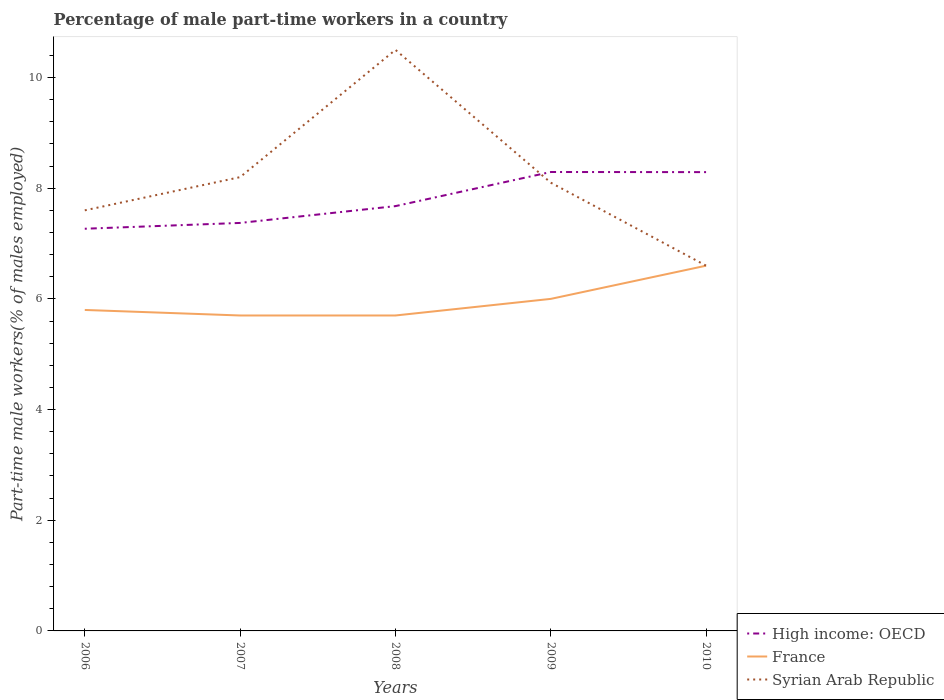Does the line corresponding to High income: OECD intersect with the line corresponding to Syrian Arab Republic?
Keep it short and to the point. Yes. Across all years, what is the maximum percentage of male part-time workers in Syrian Arab Republic?
Your answer should be compact. 6.6. In which year was the percentage of male part-time workers in High income: OECD maximum?
Ensure brevity in your answer.  2006. What is the total percentage of male part-time workers in High income: OECD in the graph?
Offer a very short reply. -0.41. What is the difference between the highest and the second highest percentage of male part-time workers in Syrian Arab Republic?
Make the answer very short. 3.9. Is the percentage of male part-time workers in Syrian Arab Republic strictly greater than the percentage of male part-time workers in France over the years?
Your answer should be very brief. No. What is the difference between two consecutive major ticks on the Y-axis?
Offer a terse response. 2. Are the values on the major ticks of Y-axis written in scientific E-notation?
Provide a succinct answer. No. Does the graph contain any zero values?
Make the answer very short. No. Does the graph contain grids?
Offer a very short reply. No. How are the legend labels stacked?
Ensure brevity in your answer.  Vertical. What is the title of the graph?
Provide a succinct answer. Percentage of male part-time workers in a country. Does "Small states" appear as one of the legend labels in the graph?
Provide a succinct answer. No. What is the label or title of the Y-axis?
Your answer should be compact. Part-time male workers(% of males employed). What is the Part-time male workers(% of males employed) in High income: OECD in 2006?
Make the answer very short. 7.27. What is the Part-time male workers(% of males employed) of France in 2006?
Offer a very short reply. 5.8. What is the Part-time male workers(% of males employed) in Syrian Arab Republic in 2006?
Offer a terse response. 7.6. What is the Part-time male workers(% of males employed) in High income: OECD in 2007?
Provide a short and direct response. 7.37. What is the Part-time male workers(% of males employed) of France in 2007?
Give a very brief answer. 5.7. What is the Part-time male workers(% of males employed) in Syrian Arab Republic in 2007?
Ensure brevity in your answer.  8.2. What is the Part-time male workers(% of males employed) in High income: OECD in 2008?
Provide a succinct answer. 7.68. What is the Part-time male workers(% of males employed) of France in 2008?
Give a very brief answer. 5.7. What is the Part-time male workers(% of males employed) in Syrian Arab Republic in 2008?
Offer a terse response. 10.5. What is the Part-time male workers(% of males employed) of High income: OECD in 2009?
Provide a short and direct response. 8.29. What is the Part-time male workers(% of males employed) in Syrian Arab Republic in 2009?
Make the answer very short. 8.1. What is the Part-time male workers(% of males employed) in High income: OECD in 2010?
Ensure brevity in your answer.  8.29. What is the Part-time male workers(% of males employed) in France in 2010?
Your answer should be compact. 6.6. What is the Part-time male workers(% of males employed) of Syrian Arab Republic in 2010?
Offer a very short reply. 6.6. Across all years, what is the maximum Part-time male workers(% of males employed) in High income: OECD?
Provide a short and direct response. 8.29. Across all years, what is the maximum Part-time male workers(% of males employed) in France?
Offer a very short reply. 6.6. Across all years, what is the maximum Part-time male workers(% of males employed) of Syrian Arab Republic?
Your answer should be compact. 10.5. Across all years, what is the minimum Part-time male workers(% of males employed) in High income: OECD?
Your answer should be compact. 7.27. Across all years, what is the minimum Part-time male workers(% of males employed) in France?
Offer a terse response. 5.7. Across all years, what is the minimum Part-time male workers(% of males employed) in Syrian Arab Republic?
Make the answer very short. 6.6. What is the total Part-time male workers(% of males employed) of High income: OECD in the graph?
Make the answer very short. 38.9. What is the total Part-time male workers(% of males employed) of France in the graph?
Your answer should be very brief. 29.8. What is the difference between the Part-time male workers(% of males employed) in High income: OECD in 2006 and that in 2007?
Provide a succinct answer. -0.1. What is the difference between the Part-time male workers(% of males employed) in High income: OECD in 2006 and that in 2008?
Keep it short and to the point. -0.41. What is the difference between the Part-time male workers(% of males employed) of High income: OECD in 2006 and that in 2009?
Keep it short and to the point. -1.03. What is the difference between the Part-time male workers(% of males employed) of France in 2006 and that in 2009?
Offer a terse response. -0.2. What is the difference between the Part-time male workers(% of males employed) of Syrian Arab Republic in 2006 and that in 2009?
Give a very brief answer. -0.5. What is the difference between the Part-time male workers(% of males employed) in High income: OECD in 2006 and that in 2010?
Your answer should be very brief. -1.02. What is the difference between the Part-time male workers(% of males employed) of High income: OECD in 2007 and that in 2008?
Provide a short and direct response. -0.3. What is the difference between the Part-time male workers(% of males employed) in Syrian Arab Republic in 2007 and that in 2008?
Ensure brevity in your answer.  -2.3. What is the difference between the Part-time male workers(% of males employed) in High income: OECD in 2007 and that in 2009?
Your response must be concise. -0.92. What is the difference between the Part-time male workers(% of males employed) in Syrian Arab Republic in 2007 and that in 2009?
Ensure brevity in your answer.  0.1. What is the difference between the Part-time male workers(% of males employed) of High income: OECD in 2007 and that in 2010?
Provide a short and direct response. -0.92. What is the difference between the Part-time male workers(% of males employed) of France in 2007 and that in 2010?
Offer a terse response. -0.9. What is the difference between the Part-time male workers(% of males employed) in Syrian Arab Republic in 2007 and that in 2010?
Provide a succinct answer. 1.6. What is the difference between the Part-time male workers(% of males employed) in High income: OECD in 2008 and that in 2009?
Offer a very short reply. -0.62. What is the difference between the Part-time male workers(% of males employed) in France in 2008 and that in 2009?
Keep it short and to the point. -0.3. What is the difference between the Part-time male workers(% of males employed) in Syrian Arab Republic in 2008 and that in 2009?
Your answer should be compact. 2.4. What is the difference between the Part-time male workers(% of males employed) of High income: OECD in 2008 and that in 2010?
Your response must be concise. -0.61. What is the difference between the Part-time male workers(% of males employed) in Syrian Arab Republic in 2008 and that in 2010?
Keep it short and to the point. 3.9. What is the difference between the Part-time male workers(% of males employed) of High income: OECD in 2009 and that in 2010?
Provide a short and direct response. 0. What is the difference between the Part-time male workers(% of males employed) of France in 2009 and that in 2010?
Your response must be concise. -0.6. What is the difference between the Part-time male workers(% of males employed) of High income: OECD in 2006 and the Part-time male workers(% of males employed) of France in 2007?
Offer a terse response. 1.57. What is the difference between the Part-time male workers(% of males employed) in High income: OECD in 2006 and the Part-time male workers(% of males employed) in Syrian Arab Republic in 2007?
Ensure brevity in your answer.  -0.93. What is the difference between the Part-time male workers(% of males employed) in High income: OECD in 2006 and the Part-time male workers(% of males employed) in France in 2008?
Your answer should be very brief. 1.57. What is the difference between the Part-time male workers(% of males employed) in High income: OECD in 2006 and the Part-time male workers(% of males employed) in Syrian Arab Republic in 2008?
Offer a very short reply. -3.23. What is the difference between the Part-time male workers(% of males employed) in High income: OECD in 2006 and the Part-time male workers(% of males employed) in France in 2009?
Your response must be concise. 1.27. What is the difference between the Part-time male workers(% of males employed) of High income: OECD in 2006 and the Part-time male workers(% of males employed) of Syrian Arab Republic in 2009?
Your answer should be very brief. -0.83. What is the difference between the Part-time male workers(% of males employed) in France in 2006 and the Part-time male workers(% of males employed) in Syrian Arab Republic in 2009?
Offer a very short reply. -2.3. What is the difference between the Part-time male workers(% of males employed) in High income: OECD in 2006 and the Part-time male workers(% of males employed) in France in 2010?
Offer a very short reply. 0.67. What is the difference between the Part-time male workers(% of males employed) of High income: OECD in 2006 and the Part-time male workers(% of males employed) of Syrian Arab Republic in 2010?
Give a very brief answer. 0.67. What is the difference between the Part-time male workers(% of males employed) in High income: OECD in 2007 and the Part-time male workers(% of males employed) in France in 2008?
Keep it short and to the point. 1.67. What is the difference between the Part-time male workers(% of males employed) in High income: OECD in 2007 and the Part-time male workers(% of males employed) in Syrian Arab Republic in 2008?
Offer a very short reply. -3.13. What is the difference between the Part-time male workers(% of males employed) of France in 2007 and the Part-time male workers(% of males employed) of Syrian Arab Republic in 2008?
Provide a succinct answer. -4.8. What is the difference between the Part-time male workers(% of males employed) of High income: OECD in 2007 and the Part-time male workers(% of males employed) of France in 2009?
Ensure brevity in your answer.  1.37. What is the difference between the Part-time male workers(% of males employed) in High income: OECD in 2007 and the Part-time male workers(% of males employed) in Syrian Arab Republic in 2009?
Offer a terse response. -0.73. What is the difference between the Part-time male workers(% of males employed) of France in 2007 and the Part-time male workers(% of males employed) of Syrian Arab Republic in 2009?
Your response must be concise. -2.4. What is the difference between the Part-time male workers(% of males employed) of High income: OECD in 2007 and the Part-time male workers(% of males employed) of France in 2010?
Ensure brevity in your answer.  0.77. What is the difference between the Part-time male workers(% of males employed) in High income: OECD in 2007 and the Part-time male workers(% of males employed) in Syrian Arab Republic in 2010?
Keep it short and to the point. 0.77. What is the difference between the Part-time male workers(% of males employed) of High income: OECD in 2008 and the Part-time male workers(% of males employed) of France in 2009?
Your answer should be compact. 1.68. What is the difference between the Part-time male workers(% of males employed) in High income: OECD in 2008 and the Part-time male workers(% of males employed) in Syrian Arab Republic in 2009?
Your response must be concise. -0.42. What is the difference between the Part-time male workers(% of males employed) of High income: OECD in 2008 and the Part-time male workers(% of males employed) of France in 2010?
Make the answer very short. 1.08. What is the difference between the Part-time male workers(% of males employed) of High income: OECD in 2008 and the Part-time male workers(% of males employed) of Syrian Arab Republic in 2010?
Your response must be concise. 1.08. What is the difference between the Part-time male workers(% of males employed) in France in 2008 and the Part-time male workers(% of males employed) in Syrian Arab Republic in 2010?
Your answer should be compact. -0.9. What is the difference between the Part-time male workers(% of males employed) of High income: OECD in 2009 and the Part-time male workers(% of males employed) of France in 2010?
Your answer should be compact. 1.69. What is the difference between the Part-time male workers(% of males employed) of High income: OECD in 2009 and the Part-time male workers(% of males employed) of Syrian Arab Republic in 2010?
Keep it short and to the point. 1.69. What is the difference between the Part-time male workers(% of males employed) in France in 2009 and the Part-time male workers(% of males employed) in Syrian Arab Republic in 2010?
Offer a very short reply. -0.6. What is the average Part-time male workers(% of males employed) in High income: OECD per year?
Ensure brevity in your answer.  7.78. What is the average Part-time male workers(% of males employed) in France per year?
Make the answer very short. 5.96. What is the average Part-time male workers(% of males employed) in Syrian Arab Republic per year?
Keep it short and to the point. 8.2. In the year 2006, what is the difference between the Part-time male workers(% of males employed) of High income: OECD and Part-time male workers(% of males employed) of France?
Keep it short and to the point. 1.47. In the year 2006, what is the difference between the Part-time male workers(% of males employed) of High income: OECD and Part-time male workers(% of males employed) of Syrian Arab Republic?
Ensure brevity in your answer.  -0.33. In the year 2007, what is the difference between the Part-time male workers(% of males employed) in High income: OECD and Part-time male workers(% of males employed) in France?
Provide a succinct answer. 1.67. In the year 2007, what is the difference between the Part-time male workers(% of males employed) of High income: OECD and Part-time male workers(% of males employed) of Syrian Arab Republic?
Your response must be concise. -0.83. In the year 2008, what is the difference between the Part-time male workers(% of males employed) of High income: OECD and Part-time male workers(% of males employed) of France?
Provide a short and direct response. 1.98. In the year 2008, what is the difference between the Part-time male workers(% of males employed) in High income: OECD and Part-time male workers(% of males employed) in Syrian Arab Republic?
Make the answer very short. -2.82. In the year 2009, what is the difference between the Part-time male workers(% of males employed) of High income: OECD and Part-time male workers(% of males employed) of France?
Your response must be concise. 2.29. In the year 2009, what is the difference between the Part-time male workers(% of males employed) in High income: OECD and Part-time male workers(% of males employed) in Syrian Arab Republic?
Give a very brief answer. 0.19. In the year 2010, what is the difference between the Part-time male workers(% of males employed) of High income: OECD and Part-time male workers(% of males employed) of France?
Your answer should be very brief. 1.69. In the year 2010, what is the difference between the Part-time male workers(% of males employed) of High income: OECD and Part-time male workers(% of males employed) of Syrian Arab Republic?
Ensure brevity in your answer.  1.69. What is the ratio of the Part-time male workers(% of males employed) in High income: OECD in 2006 to that in 2007?
Provide a succinct answer. 0.99. What is the ratio of the Part-time male workers(% of males employed) in France in 2006 to that in 2007?
Offer a terse response. 1.02. What is the ratio of the Part-time male workers(% of males employed) of Syrian Arab Republic in 2006 to that in 2007?
Make the answer very short. 0.93. What is the ratio of the Part-time male workers(% of males employed) in High income: OECD in 2006 to that in 2008?
Your answer should be very brief. 0.95. What is the ratio of the Part-time male workers(% of males employed) of France in 2006 to that in 2008?
Offer a terse response. 1.02. What is the ratio of the Part-time male workers(% of males employed) in Syrian Arab Republic in 2006 to that in 2008?
Make the answer very short. 0.72. What is the ratio of the Part-time male workers(% of males employed) of High income: OECD in 2006 to that in 2009?
Offer a terse response. 0.88. What is the ratio of the Part-time male workers(% of males employed) in France in 2006 to that in 2009?
Your response must be concise. 0.97. What is the ratio of the Part-time male workers(% of males employed) in Syrian Arab Republic in 2006 to that in 2009?
Your answer should be very brief. 0.94. What is the ratio of the Part-time male workers(% of males employed) of High income: OECD in 2006 to that in 2010?
Ensure brevity in your answer.  0.88. What is the ratio of the Part-time male workers(% of males employed) of France in 2006 to that in 2010?
Your answer should be compact. 0.88. What is the ratio of the Part-time male workers(% of males employed) of Syrian Arab Republic in 2006 to that in 2010?
Make the answer very short. 1.15. What is the ratio of the Part-time male workers(% of males employed) of High income: OECD in 2007 to that in 2008?
Offer a terse response. 0.96. What is the ratio of the Part-time male workers(% of males employed) in France in 2007 to that in 2008?
Keep it short and to the point. 1. What is the ratio of the Part-time male workers(% of males employed) of Syrian Arab Republic in 2007 to that in 2008?
Your response must be concise. 0.78. What is the ratio of the Part-time male workers(% of males employed) of High income: OECD in 2007 to that in 2009?
Ensure brevity in your answer.  0.89. What is the ratio of the Part-time male workers(% of males employed) of Syrian Arab Republic in 2007 to that in 2009?
Keep it short and to the point. 1.01. What is the ratio of the Part-time male workers(% of males employed) of High income: OECD in 2007 to that in 2010?
Your response must be concise. 0.89. What is the ratio of the Part-time male workers(% of males employed) in France in 2007 to that in 2010?
Keep it short and to the point. 0.86. What is the ratio of the Part-time male workers(% of males employed) in Syrian Arab Republic in 2007 to that in 2010?
Your response must be concise. 1.24. What is the ratio of the Part-time male workers(% of males employed) in High income: OECD in 2008 to that in 2009?
Offer a terse response. 0.93. What is the ratio of the Part-time male workers(% of males employed) in France in 2008 to that in 2009?
Keep it short and to the point. 0.95. What is the ratio of the Part-time male workers(% of males employed) in Syrian Arab Republic in 2008 to that in 2009?
Offer a terse response. 1.3. What is the ratio of the Part-time male workers(% of males employed) in High income: OECD in 2008 to that in 2010?
Provide a succinct answer. 0.93. What is the ratio of the Part-time male workers(% of males employed) in France in 2008 to that in 2010?
Offer a very short reply. 0.86. What is the ratio of the Part-time male workers(% of males employed) of Syrian Arab Republic in 2008 to that in 2010?
Give a very brief answer. 1.59. What is the ratio of the Part-time male workers(% of males employed) of High income: OECD in 2009 to that in 2010?
Your answer should be very brief. 1. What is the ratio of the Part-time male workers(% of males employed) in France in 2009 to that in 2010?
Provide a succinct answer. 0.91. What is the ratio of the Part-time male workers(% of males employed) of Syrian Arab Republic in 2009 to that in 2010?
Offer a terse response. 1.23. What is the difference between the highest and the second highest Part-time male workers(% of males employed) in High income: OECD?
Offer a very short reply. 0. What is the difference between the highest and the second highest Part-time male workers(% of males employed) of Syrian Arab Republic?
Provide a succinct answer. 2.3. What is the difference between the highest and the lowest Part-time male workers(% of males employed) in High income: OECD?
Provide a short and direct response. 1.03. What is the difference between the highest and the lowest Part-time male workers(% of males employed) in France?
Provide a short and direct response. 0.9. 